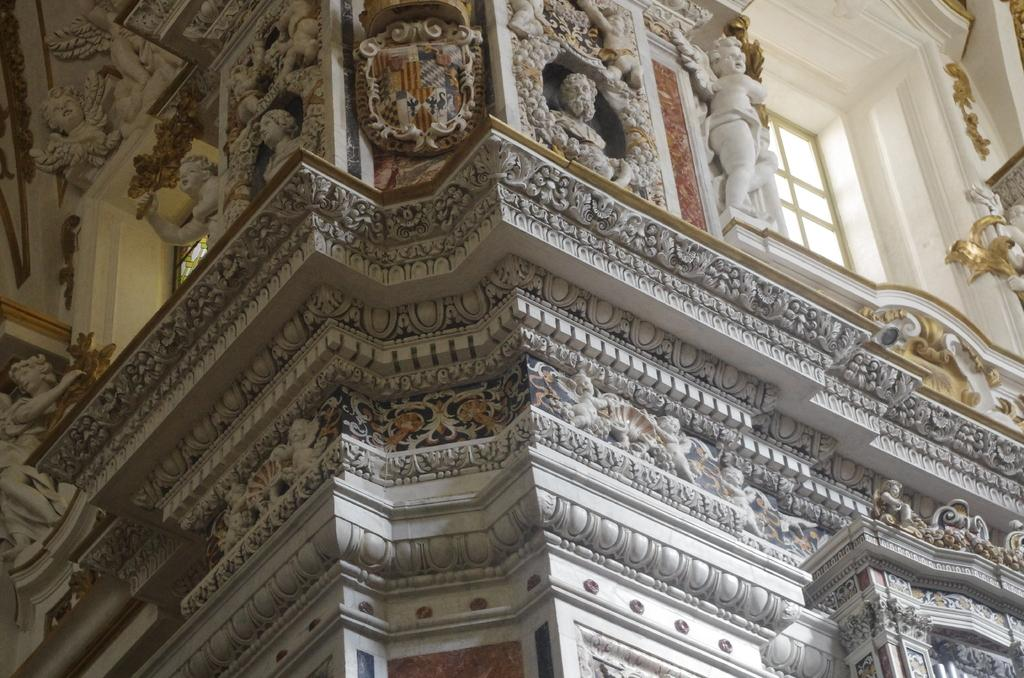What type of artwork can be seen on the walls of the building in the image? There is a sculpture on the walls of the building in the image. What architectural feature allows natural light to enter the building? There are windows visible in the image. How many visitors can be seen in the image? There is no reference to visitors in the image, so it is not possible to determine how many visitors might be present. 